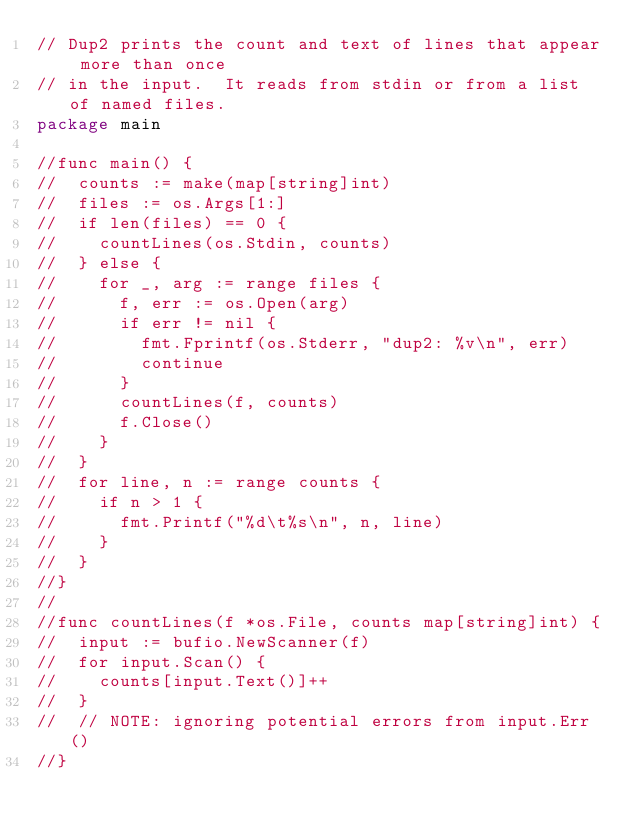Convert code to text. <code><loc_0><loc_0><loc_500><loc_500><_Go_>// Dup2 prints the count and text of lines that appear more than once
// in the input.  It reads from stdin or from a list of named files.
package main

//func main() {
//	counts := make(map[string]int)
//	files := os.Args[1:]
//	if len(files) == 0 {
//		countLines(os.Stdin, counts)
//	} else {
//		for _, arg := range files {
//			f, err := os.Open(arg)
//			if err != nil {
//				fmt.Fprintf(os.Stderr, "dup2: %v\n", err)
//				continue
//			}
//			countLines(f, counts)
//			f.Close()
//		}
//	}
//	for line, n := range counts {
//		if n > 1 {
//			fmt.Printf("%d\t%s\n", n, line)
//		}
//	}
//}
//
//func countLines(f *os.File, counts map[string]int) {
//	input := bufio.NewScanner(f)
//	for input.Scan() {
//		counts[input.Text()]++
//	}
//	// NOTE: ignoring potential errors from input.Err()
//}
</code> 